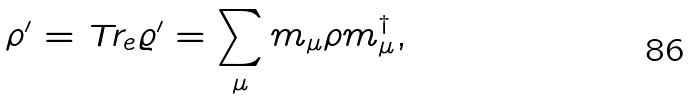<formula> <loc_0><loc_0><loc_500><loc_500>\rho ^ { \prime } = { \text {Tr} } _ { e } \varrho ^ { \prime } = \sum _ { \mu } m _ { \mu } \rho m _ { \mu } ^ { \dagger } ,</formula> 